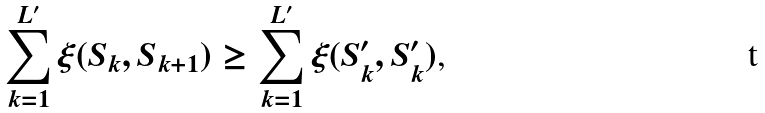<formula> <loc_0><loc_0><loc_500><loc_500>\sum _ { k = 1 } ^ { L ^ { \prime } } \xi ( S _ { k } , S _ { k + 1 } ) \geq \sum _ { k = 1 } ^ { L ^ { \prime } } \xi ( S _ { k } ^ { \prime } , S _ { k } ^ { \prime } ) \text  ,</formula> 